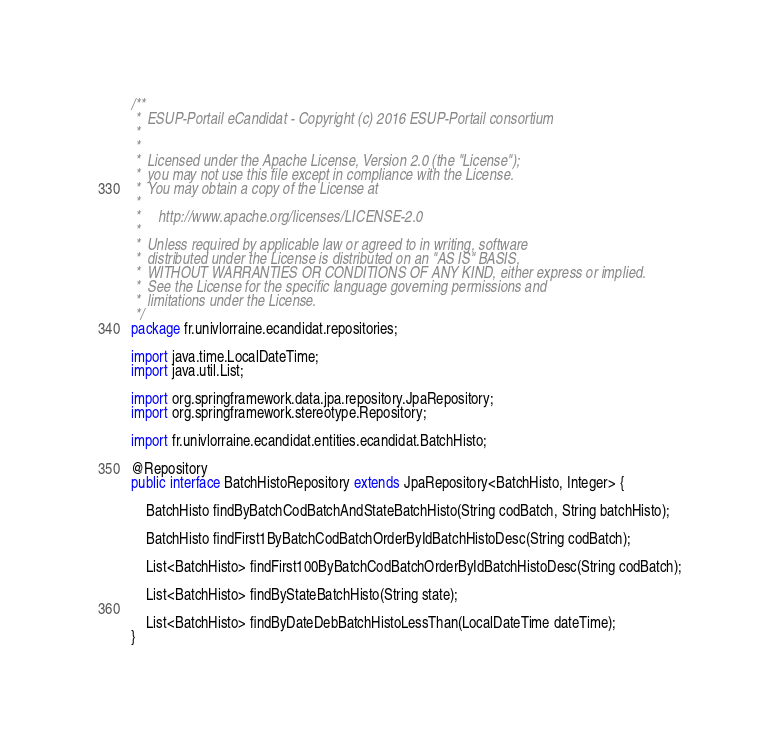Convert code to text. <code><loc_0><loc_0><loc_500><loc_500><_Java_>/**
 *  ESUP-Portail eCandidat - Copyright (c) 2016 ESUP-Portail consortium
 *
 *
 *  Licensed under the Apache License, Version 2.0 (the "License");
 *  you may not use this file except in compliance with the License.
 *  You may obtain a copy of the License at
 *
 *     http://www.apache.org/licenses/LICENSE-2.0
 *
 *  Unless required by applicable law or agreed to in writing, software
 *  distributed under the License is distributed on an "AS IS" BASIS,
 *  WITHOUT WARRANTIES OR CONDITIONS OF ANY KIND, either express or implied.
 *  See the License for the specific language governing permissions and
 *  limitations under the License.
 */
package fr.univlorraine.ecandidat.repositories;

import java.time.LocalDateTime;
import java.util.List;

import org.springframework.data.jpa.repository.JpaRepository;
import org.springframework.stereotype.Repository;

import fr.univlorraine.ecandidat.entities.ecandidat.BatchHisto;

@Repository
public interface BatchHistoRepository extends JpaRepository<BatchHisto, Integer> {
	
	BatchHisto findByBatchCodBatchAndStateBatchHisto(String codBatch, String batchHisto);
	
	BatchHisto findFirst1ByBatchCodBatchOrderByIdBatchHistoDesc(String codBatch);
	
	List<BatchHisto> findFirst100ByBatchCodBatchOrderByIdBatchHistoDesc(String codBatch);

	List<BatchHisto> findByStateBatchHisto(String state);
	
	List<BatchHisto> findByDateDebBatchHistoLessThan(LocalDateTime dateTime);
}
</code> 